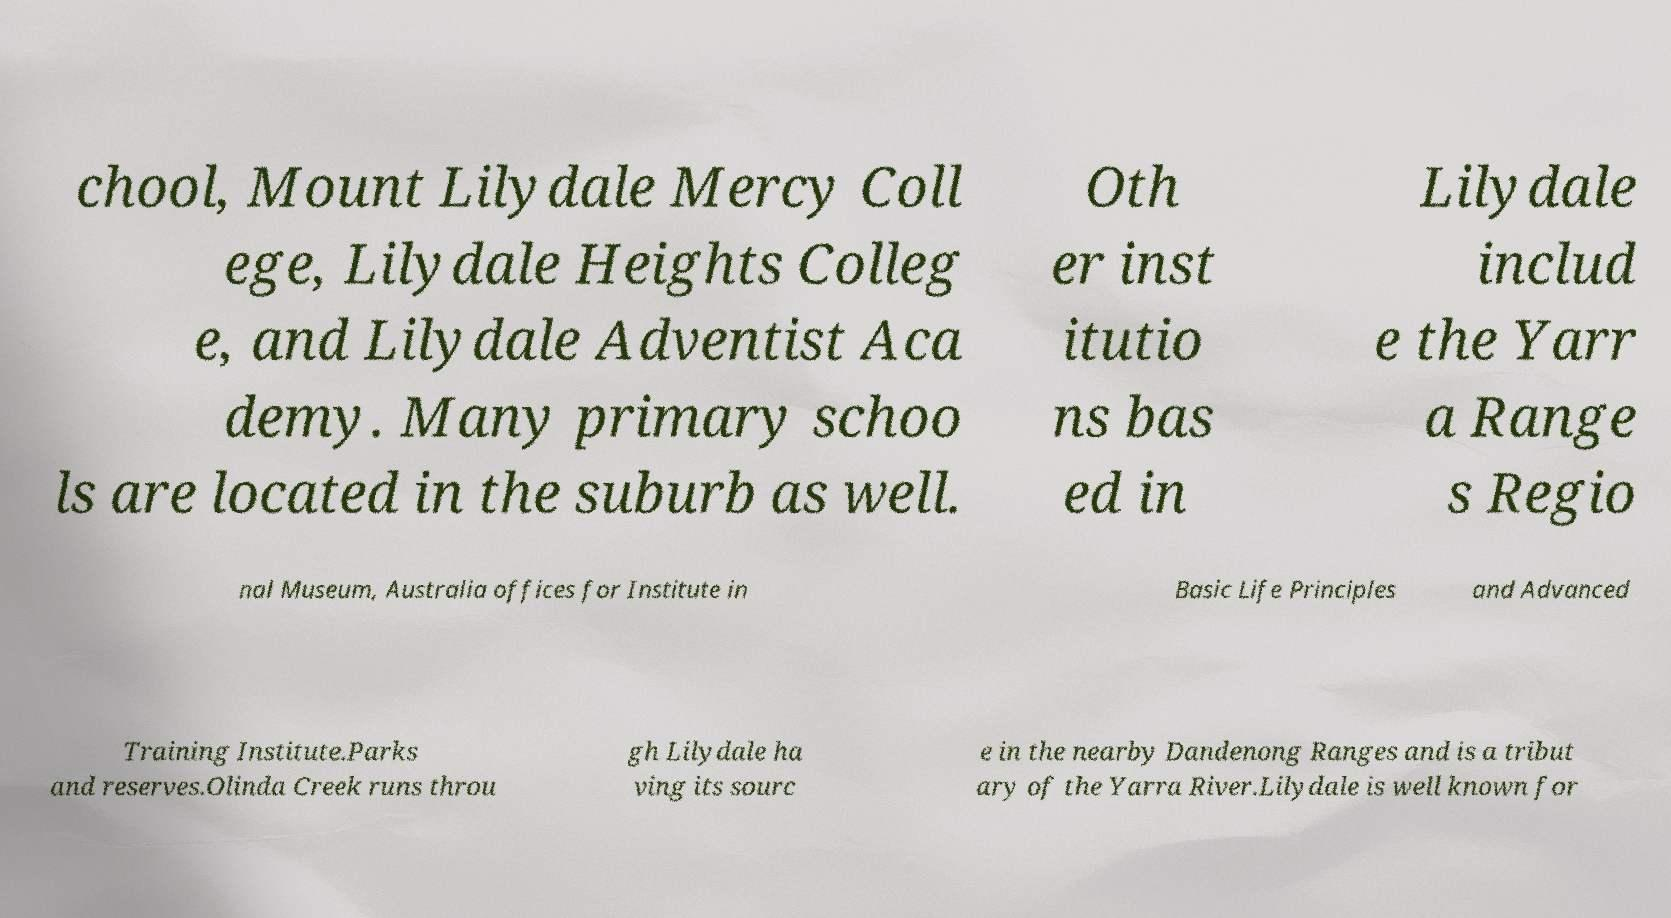What messages or text are displayed in this image? I need them in a readable, typed format. chool, Mount Lilydale Mercy Coll ege, Lilydale Heights Colleg e, and Lilydale Adventist Aca demy. Many primary schoo ls are located in the suburb as well. Oth er inst itutio ns bas ed in Lilydale includ e the Yarr a Range s Regio nal Museum, Australia offices for Institute in Basic Life Principles and Advanced Training Institute.Parks and reserves.Olinda Creek runs throu gh Lilydale ha ving its sourc e in the nearby Dandenong Ranges and is a tribut ary of the Yarra River.Lilydale is well known for 